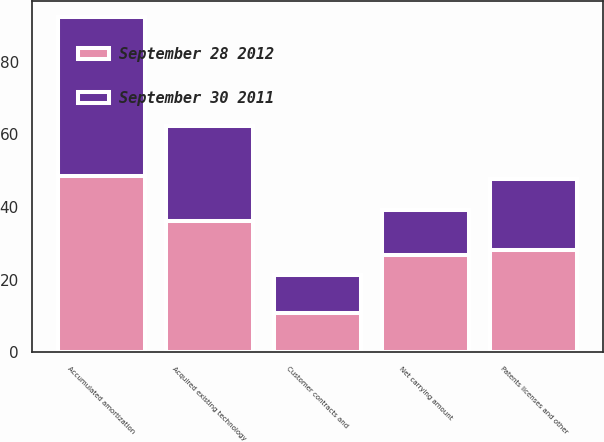Convert chart to OTSL. <chart><loc_0><loc_0><loc_500><loc_500><stacked_bar_chart><ecel><fcel>Acquired existing technology<fcel>Patents licenses and other<fcel>Customer contracts and<fcel>Accumulated amortization<fcel>Net carrying amount<nl><fcel>September 28 2012<fcel>36.3<fcel>28.1<fcel>10.9<fcel>48.5<fcel>26.8<nl><fcel>September 30 2011<fcel>26<fcel>19.6<fcel>10.4<fcel>43.7<fcel>12.3<nl></chart> 